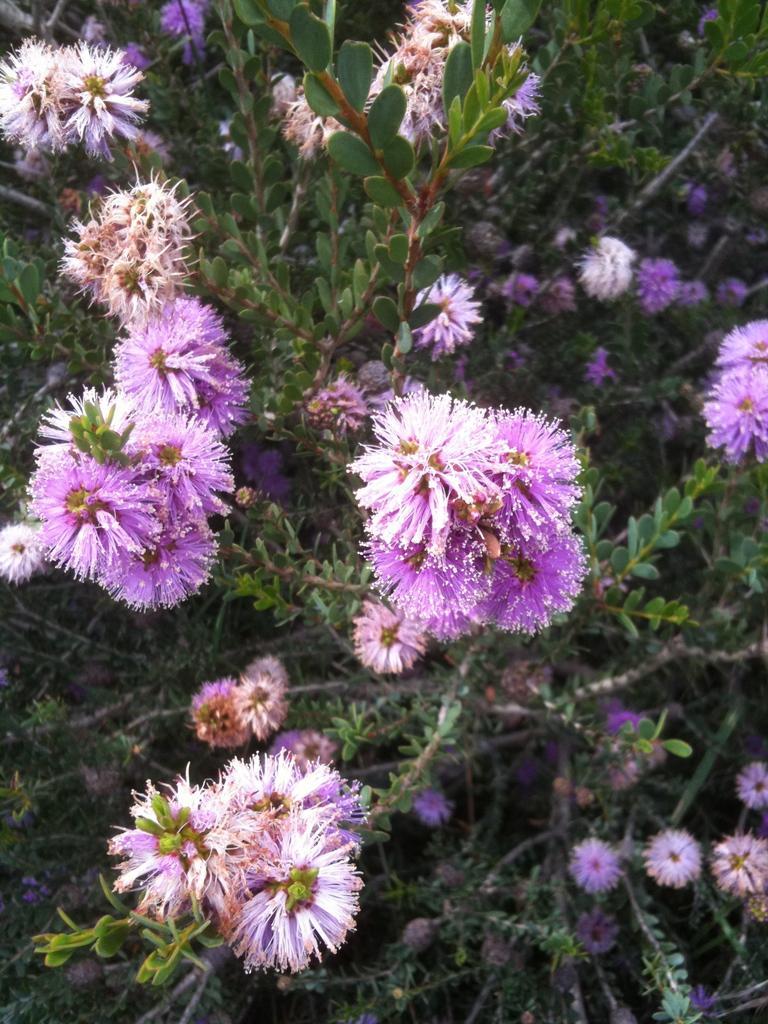In one or two sentences, can you explain what this image depicts? There are many plants with beautiful purple flowers. 